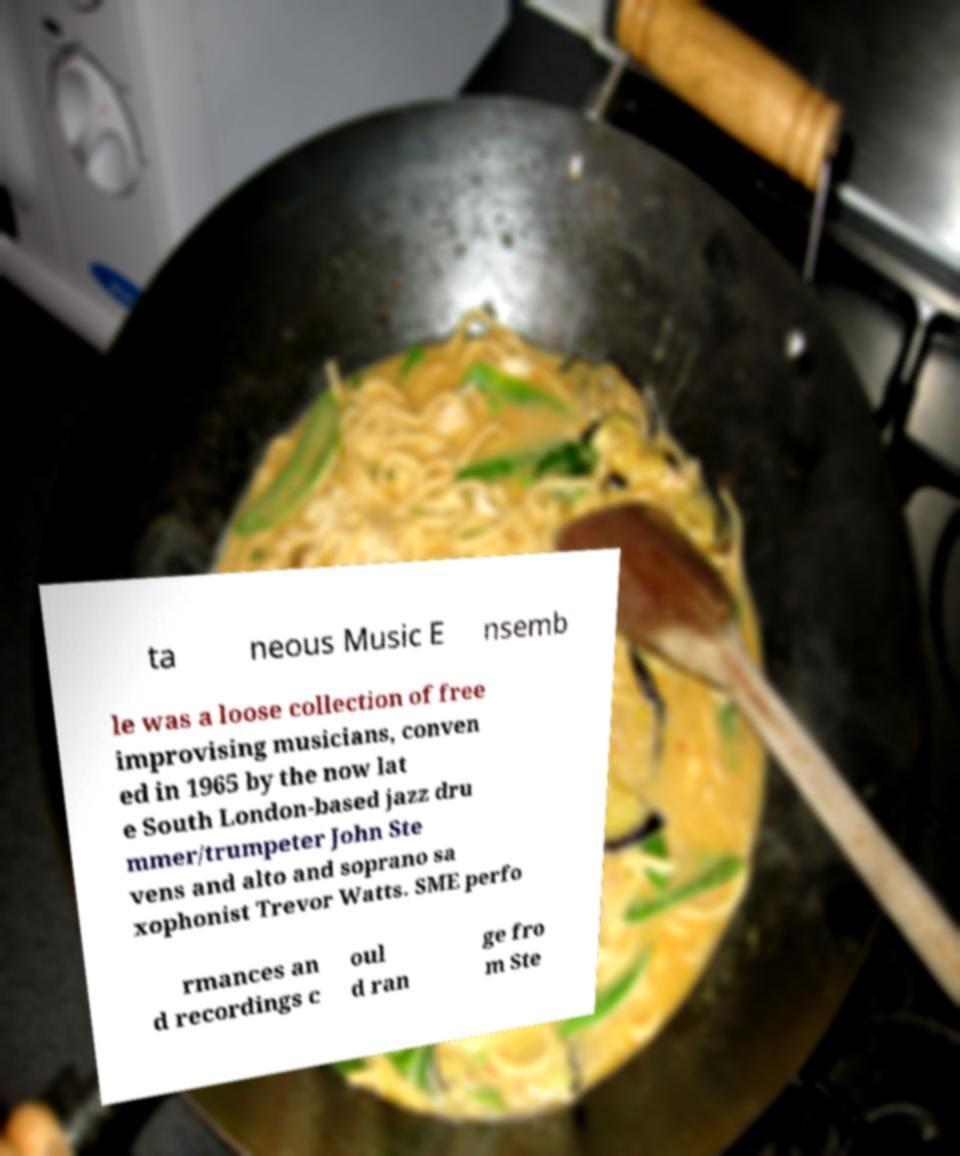Please read and relay the text visible in this image. What does it say? ta neous Music E nsemb le was a loose collection of free improvising musicians, conven ed in 1965 by the now lat e South London-based jazz dru mmer/trumpeter John Ste vens and alto and soprano sa xophonist Trevor Watts. SME perfo rmances an d recordings c oul d ran ge fro m Ste 